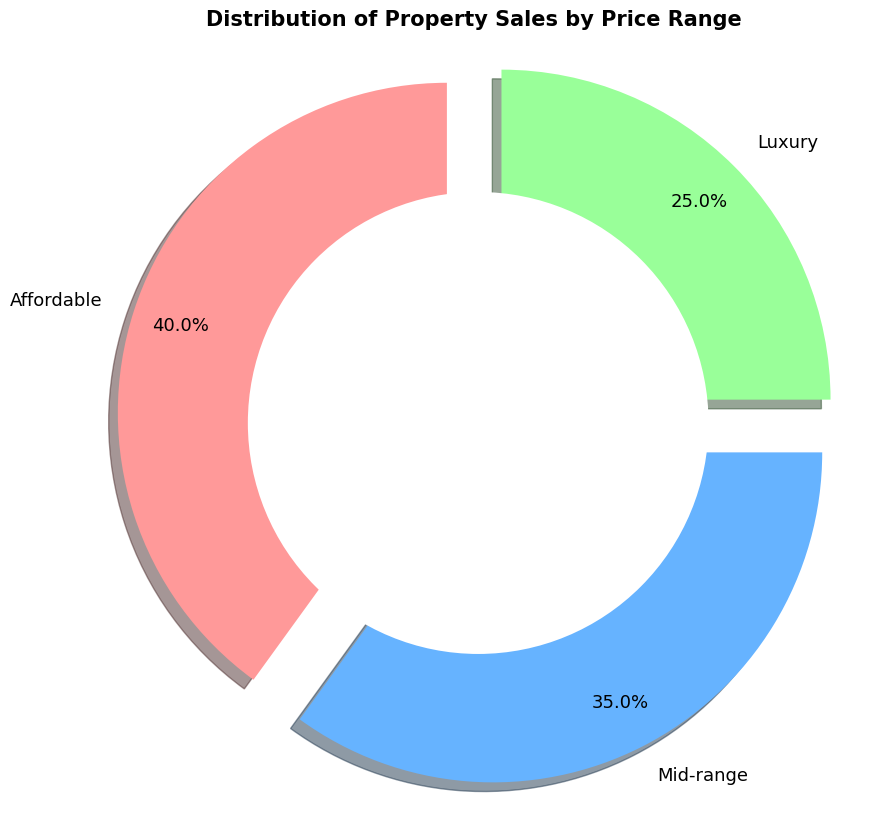What percentage of property sales are in the affordable range? The affordable range is labeled on the pie chart and shows 40%.
Answer: 40% Which price range has the least percentage of sales? By comparing the percentages, the luxury range has the smallest slice, which is 25%.
Answer: Luxury How much more are the mid-range property sales compared to the luxury range? The mid-range is 35%, and the luxury range is 25%. Subtract 25% from 35% to find the difference: 35% - 25% = 10%.
Answer: 10% What is the total percentage of sales for the affordable and mid-range properties combined? Add the percentages of affordable (40%) and mid-range (35%) properties: 40% + 35% = 75%.
Answer: 75% If you were to double the percentage share of luxury property sales, what would it be? Double the luxury percentage (25%): 25% × 2 = 50%.
Answer: 50% How does the percentage of mid-range sales compare to the total sales of luxury and affordable properties combined? Add the luxury (25%) and affordable (40%) sales: 25% + 40% = 65%. The mid-range (35%) is less than the total of luxury and affordable (65%).
Answer: Less What color represents the affordable price range? The affordable section of the pie chart is colored in red.
Answer: Red How many categories are represented in the pie chart? The pie chart has slices for three categories: affordable, mid-range, and luxury.
Answer: Three If the mid-range sales increased by 5%, what would be the new percentage of mid-range sales? Add 5% to the existing mid-range percentage (35%): 35% + 5% = 40%.
Answer: 40% Is the percentage of mid-range property sales more than one-third of the total distribution? One-third of 100% is approximately 33.33%. The mid-range is 35%, which is more than 33.33%.
Answer: Yes 